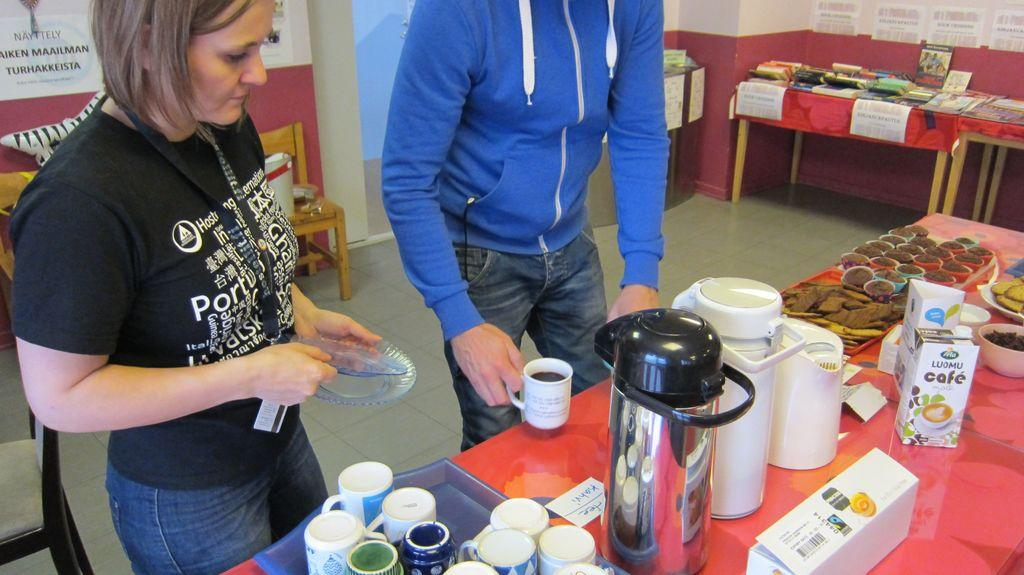<image>
Share a concise interpretation of the image provided. people standing behind a table with a box that says 'cafe' on it 